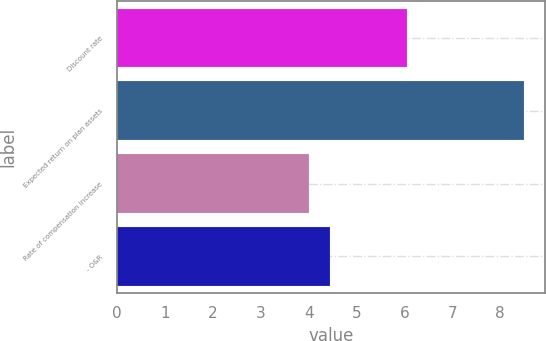Convert chart. <chart><loc_0><loc_0><loc_500><loc_500><bar_chart><fcel>Discount rate<fcel>Expected return on plan assets<fcel>Rate of compensation increase<fcel>- O&R<nl><fcel>6.05<fcel>8.5<fcel>4<fcel>4.45<nl></chart> 